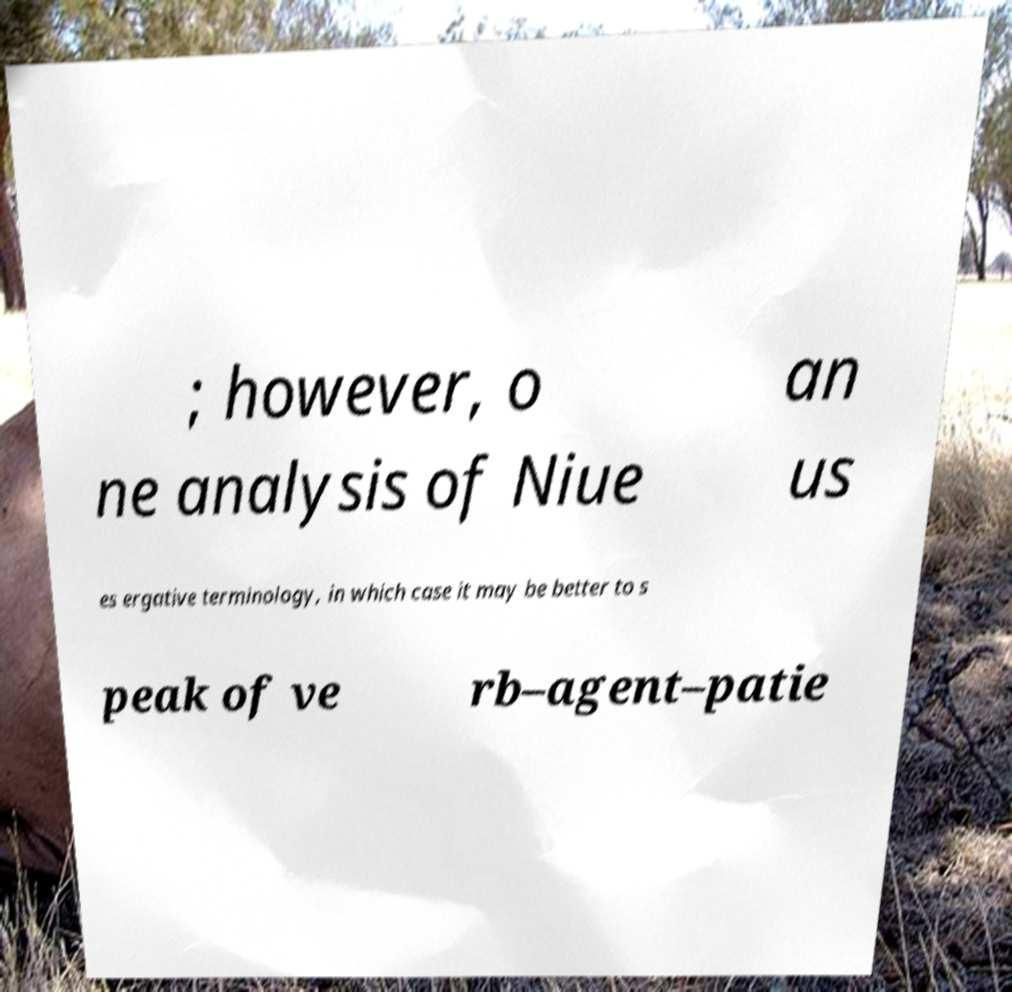Please identify and transcribe the text found in this image. ; however, o ne analysis of Niue an us es ergative terminology, in which case it may be better to s peak of ve rb–agent–patie 